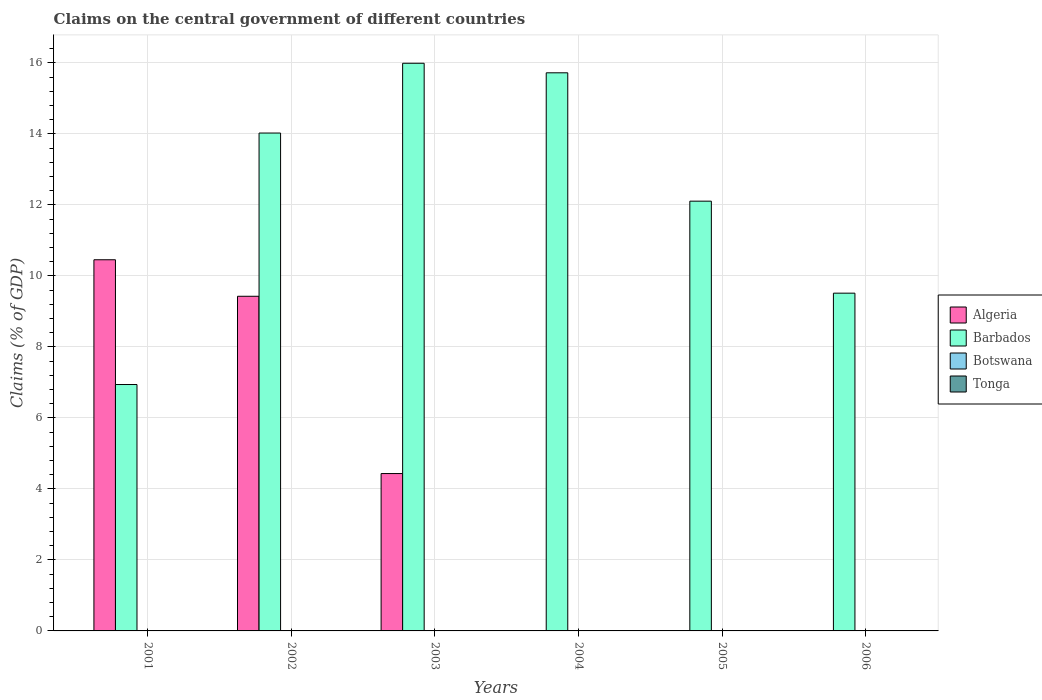How many different coloured bars are there?
Provide a succinct answer. 2. Are the number of bars per tick equal to the number of legend labels?
Your answer should be very brief. No. What is the percentage of GDP claimed on the central government in Barbados in 2001?
Make the answer very short. 6.94. Across all years, what is the maximum percentage of GDP claimed on the central government in Algeria?
Your answer should be compact. 10.45. Across all years, what is the minimum percentage of GDP claimed on the central government in Barbados?
Your answer should be very brief. 6.94. In which year was the percentage of GDP claimed on the central government in Algeria maximum?
Give a very brief answer. 2001. What is the difference between the percentage of GDP claimed on the central government in Barbados in 2004 and that in 2006?
Your answer should be very brief. 6.21. What is the difference between the percentage of GDP claimed on the central government in Tonga in 2001 and the percentage of GDP claimed on the central government in Algeria in 2006?
Your response must be concise. 0. What is the ratio of the percentage of GDP claimed on the central government in Barbados in 2003 to that in 2004?
Offer a terse response. 1.02. What is the difference between the highest and the second highest percentage of GDP claimed on the central government in Algeria?
Make the answer very short. 1.03. What is the difference between the highest and the lowest percentage of GDP claimed on the central government in Algeria?
Provide a short and direct response. 10.45. In how many years, is the percentage of GDP claimed on the central government in Botswana greater than the average percentage of GDP claimed on the central government in Botswana taken over all years?
Make the answer very short. 0. Is the sum of the percentage of GDP claimed on the central government in Barbados in 2003 and 2006 greater than the maximum percentage of GDP claimed on the central government in Algeria across all years?
Provide a short and direct response. Yes. Is it the case that in every year, the sum of the percentage of GDP claimed on the central government in Algeria and percentage of GDP claimed on the central government in Botswana is greater than the sum of percentage of GDP claimed on the central government in Barbados and percentage of GDP claimed on the central government in Tonga?
Offer a terse response. No. Is it the case that in every year, the sum of the percentage of GDP claimed on the central government in Algeria and percentage of GDP claimed on the central government in Botswana is greater than the percentage of GDP claimed on the central government in Tonga?
Provide a short and direct response. No. Are all the bars in the graph horizontal?
Provide a succinct answer. No. What is the difference between two consecutive major ticks on the Y-axis?
Keep it short and to the point. 2. Does the graph contain grids?
Your answer should be compact. Yes. Where does the legend appear in the graph?
Offer a very short reply. Center right. How are the legend labels stacked?
Provide a short and direct response. Vertical. What is the title of the graph?
Your answer should be very brief. Claims on the central government of different countries. What is the label or title of the Y-axis?
Your answer should be very brief. Claims (% of GDP). What is the Claims (% of GDP) in Algeria in 2001?
Your response must be concise. 10.45. What is the Claims (% of GDP) in Barbados in 2001?
Your answer should be compact. 6.94. What is the Claims (% of GDP) in Botswana in 2001?
Your answer should be compact. 0. What is the Claims (% of GDP) of Tonga in 2001?
Offer a terse response. 0. What is the Claims (% of GDP) in Algeria in 2002?
Offer a very short reply. 9.43. What is the Claims (% of GDP) of Barbados in 2002?
Your answer should be compact. 14.02. What is the Claims (% of GDP) in Tonga in 2002?
Give a very brief answer. 0. What is the Claims (% of GDP) of Algeria in 2003?
Keep it short and to the point. 4.43. What is the Claims (% of GDP) in Barbados in 2003?
Make the answer very short. 15.99. What is the Claims (% of GDP) in Botswana in 2003?
Your answer should be compact. 0. What is the Claims (% of GDP) of Barbados in 2004?
Provide a short and direct response. 15.72. What is the Claims (% of GDP) in Botswana in 2004?
Give a very brief answer. 0. What is the Claims (% of GDP) of Tonga in 2004?
Give a very brief answer. 0. What is the Claims (% of GDP) in Algeria in 2005?
Give a very brief answer. 0. What is the Claims (% of GDP) in Barbados in 2005?
Offer a very short reply. 12.1. What is the Claims (% of GDP) in Algeria in 2006?
Your answer should be compact. 0. What is the Claims (% of GDP) of Barbados in 2006?
Make the answer very short. 9.51. Across all years, what is the maximum Claims (% of GDP) in Algeria?
Give a very brief answer. 10.45. Across all years, what is the maximum Claims (% of GDP) of Barbados?
Offer a very short reply. 15.99. Across all years, what is the minimum Claims (% of GDP) in Barbados?
Provide a succinct answer. 6.94. What is the total Claims (% of GDP) of Algeria in the graph?
Provide a succinct answer. 24.31. What is the total Claims (% of GDP) in Barbados in the graph?
Offer a very short reply. 74.29. What is the difference between the Claims (% of GDP) in Algeria in 2001 and that in 2002?
Your answer should be very brief. 1.03. What is the difference between the Claims (% of GDP) of Barbados in 2001 and that in 2002?
Ensure brevity in your answer.  -7.08. What is the difference between the Claims (% of GDP) of Algeria in 2001 and that in 2003?
Your answer should be compact. 6.02. What is the difference between the Claims (% of GDP) of Barbados in 2001 and that in 2003?
Provide a succinct answer. -9.05. What is the difference between the Claims (% of GDP) in Barbados in 2001 and that in 2004?
Provide a succinct answer. -8.78. What is the difference between the Claims (% of GDP) of Barbados in 2001 and that in 2005?
Provide a short and direct response. -5.16. What is the difference between the Claims (% of GDP) in Barbados in 2001 and that in 2006?
Your answer should be compact. -2.57. What is the difference between the Claims (% of GDP) of Algeria in 2002 and that in 2003?
Your response must be concise. 4.99. What is the difference between the Claims (% of GDP) of Barbados in 2002 and that in 2003?
Give a very brief answer. -1.97. What is the difference between the Claims (% of GDP) in Barbados in 2002 and that in 2004?
Keep it short and to the point. -1.7. What is the difference between the Claims (% of GDP) in Barbados in 2002 and that in 2005?
Your response must be concise. 1.92. What is the difference between the Claims (% of GDP) in Barbados in 2002 and that in 2006?
Offer a very short reply. 4.51. What is the difference between the Claims (% of GDP) in Barbados in 2003 and that in 2004?
Your answer should be very brief. 0.27. What is the difference between the Claims (% of GDP) of Barbados in 2003 and that in 2005?
Provide a succinct answer. 3.88. What is the difference between the Claims (% of GDP) in Barbados in 2003 and that in 2006?
Your response must be concise. 6.48. What is the difference between the Claims (% of GDP) of Barbados in 2004 and that in 2005?
Your response must be concise. 3.62. What is the difference between the Claims (% of GDP) in Barbados in 2004 and that in 2006?
Ensure brevity in your answer.  6.21. What is the difference between the Claims (% of GDP) of Barbados in 2005 and that in 2006?
Ensure brevity in your answer.  2.59. What is the difference between the Claims (% of GDP) of Algeria in 2001 and the Claims (% of GDP) of Barbados in 2002?
Offer a terse response. -3.57. What is the difference between the Claims (% of GDP) of Algeria in 2001 and the Claims (% of GDP) of Barbados in 2003?
Your answer should be compact. -5.53. What is the difference between the Claims (% of GDP) in Algeria in 2001 and the Claims (% of GDP) in Barbados in 2004?
Offer a very short reply. -5.27. What is the difference between the Claims (% of GDP) in Algeria in 2001 and the Claims (% of GDP) in Barbados in 2005?
Make the answer very short. -1.65. What is the difference between the Claims (% of GDP) of Algeria in 2001 and the Claims (% of GDP) of Barbados in 2006?
Your answer should be very brief. 0.94. What is the difference between the Claims (% of GDP) of Algeria in 2002 and the Claims (% of GDP) of Barbados in 2003?
Your response must be concise. -6.56. What is the difference between the Claims (% of GDP) in Algeria in 2002 and the Claims (% of GDP) in Barbados in 2004?
Offer a terse response. -6.29. What is the difference between the Claims (% of GDP) of Algeria in 2002 and the Claims (% of GDP) of Barbados in 2005?
Provide a succinct answer. -2.68. What is the difference between the Claims (% of GDP) in Algeria in 2002 and the Claims (% of GDP) in Barbados in 2006?
Give a very brief answer. -0.09. What is the difference between the Claims (% of GDP) of Algeria in 2003 and the Claims (% of GDP) of Barbados in 2004?
Provide a short and direct response. -11.29. What is the difference between the Claims (% of GDP) of Algeria in 2003 and the Claims (% of GDP) of Barbados in 2005?
Your response must be concise. -7.67. What is the difference between the Claims (% of GDP) in Algeria in 2003 and the Claims (% of GDP) in Barbados in 2006?
Your response must be concise. -5.08. What is the average Claims (% of GDP) of Algeria per year?
Your answer should be very brief. 4.05. What is the average Claims (% of GDP) of Barbados per year?
Make the answer very short. 12.38. What is the average Claims (% of GDP) of Botswana per year?
Offer a very short reply. 0. What is the average Claims (% of GDP) in Tonga per year?
Offer a very short reply. 0. In the year 2001, what is the difference between the Claims (% of GDP) of Algeria and Claims (% of GDP) of Barbados?
Give a very brief answer. 3.51. In the year 2002, what is the difference between the Claims (% of GDP) of Algeria and Claims (% of GDP) of Barbados?
Give a very brief answer. -4.6. In the year 2003, what is the difference between the Claims (% of GDP) in Algeria and Claims (% of GDP) in Barbados?
Make the answer very short. -11.56. What is the ratio of the Claims (% of GDP) in Algeria in 2001 to that in 2002?
Provide a short and direct response. 1.11. What is the ratio of the Claims (% of GDP) of Barbados in 2001 to that in 2002?
Your answer should be compact. 0.49. What is the ratio of the Claims (% of GDP) of Algeria in 2001 to that in 2003?
Your answer should be compact. 2.36. What is the ratio of the Claims (% of GDP) in Barbados in 2001 to that in 2003?
Your response must be concise. 0.43. What is the ratio of the Claims (% of GDP) of Barbados in 2001 to that in 2004?
Your answer should be compact. 0.44. What is the ratio of the Claims (% of GDP) in Barbados in 2001 to that in 2005?
Offer a terse response. 0.57. What is the ratio of the Claims (% of GDP) of Barbados in 2001 to that in 2006?
Offer a terse response. 0.73. What is the ratio of the Claims (% of GDP) in Algeria in 2002 to that in 2003?
Offer a terse response. 2.13. What is the ratio of the Claims (% of GDP) in Barbados in 2002 to that in 2003?
Your answer should be compact. 0.88. What is the ratio of the Claims (% of GDP) of Barbados in 2002 to that in 2004?
Offer a very short reply. 0.89. What is the ratio of the Claims (% of GDP) of Barbados in 2002 to that in 2005?
Offer a terse response. 1.16. What is the ratio of the Claims (% of GDP) of Barbados in 2002 to that in 2006?
Offer a very short reply. 1.47. What is the ratio of the Claims (% of GDP) in Barbados in 2003 to that in 2004?
Provide a succinct answer. 1.02. What is the ratio of the Claims (% of GDP) of Barbados in 2003 to that in 2005?
Provide a short and direct response. 1.32. What is the ratio of the Claims (% of GDP) in Barbados in 2003 to that in 2006?
Provide a succinct answer. 1.68. What is the ratio of the Claims (% of GDP) in Barbados in 2004 to that in 2005?
Offer a very short reply. 1.3. What is the ratio of the Claims (% of GDP) in Barbados in 2004 to that in 2006?
Ensure brevity in your answer.  1.65. What is the ratio of the Claims (% of GDP) of Barbados in 2005 to that in 2006?
Keep it short and to the point. 1.27. What is the difference between the highest and the second highest Claims (% of GDP) of Algeria?
Make the answer very short. 1.03. What is the difference between the highest and the second highest Claims (% of GDP) in Barbados?
Your response must be concise. 0.27. What is the difference between the highest and the lowest Claims (% of GDP) in Algeria?
Your answer should be very brief. 10.45. What is the difference between the highest and the lowest Claims (% of GDP) in Barbados?
Provide a short and direct response. 9.05. 